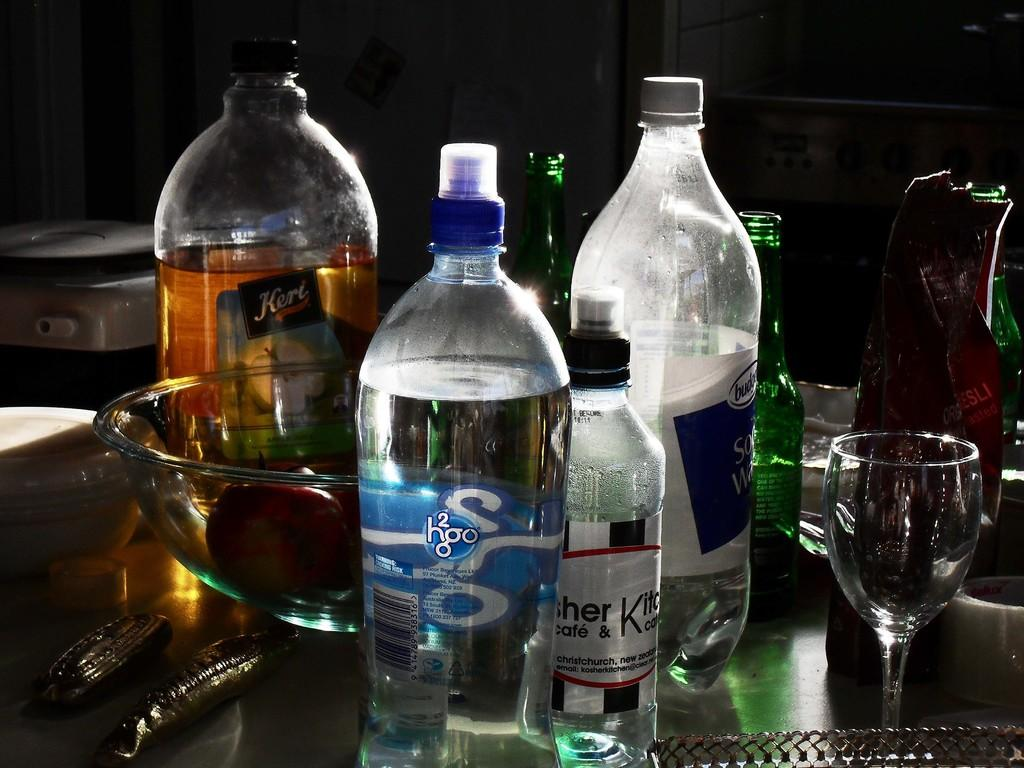What type of glass is present in the image? There is a wine glass in the image. What other beverage containers can be seen in the image? There is a water bottle and a soda bottle in the image. What type of dishware is present in the image? There is a bowl in the image. Are there any larger versions of the wine glass in the image? Yes, there is a big wine bottle in the image. How many legs are visible on the table supporting the wine glass in the image? There is no table visible in the image, so it is not possible to determine the number of legs supporting the wine glass. 